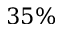<formula> <loc_0><loc_0><loc_500><loc_500>3 5 \%</formula> 